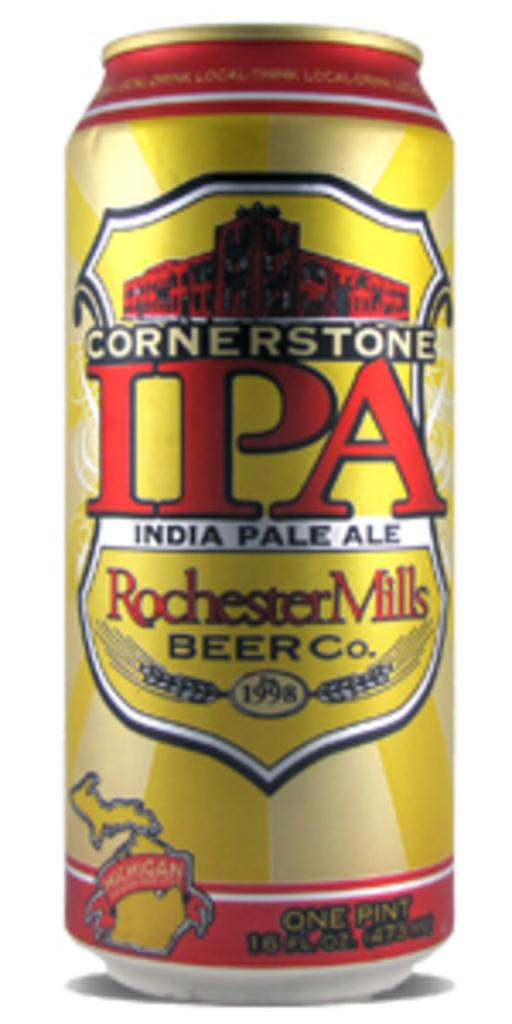<image>
Describe the image concisely. A can of Cornerstone IPA by Rochester Mills Beer Company. 